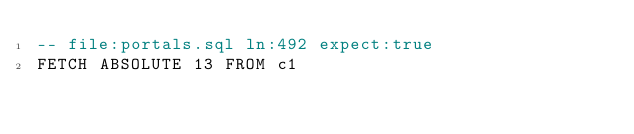Convert code to text. <code><loc_0><loc_0><loc_500><loc_500><_SQL_>-- file:portals.sql ln:492 expect:true
FETCH ABSOLUTE 13 FROM c1
</code> 